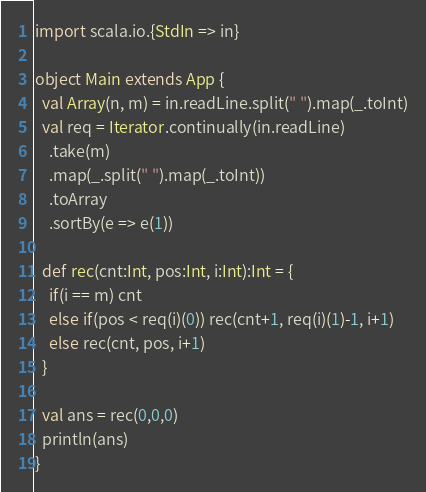Convert code to text. <code><loc_0><loc_0><loc_500><loc_500><_Scala_>import scala.io.{StdIn => in}

object Main extends App {
  val Array(n, m) = in.readLine.split(" ").map(_.toInt)
  val req = Iterator.continually(in.readLine)
    .take(m)
    .map(_.split(" ").map(_.toInt))
    .toArray
    .sortBy(e => e(1))

  def rec(cnt:Int, pos:Int, i:Int):Int = {
    if(i == m) cnt
    else if(pos < req(i)(0)) rec(cnt+1, req(i)(1)-1, i+1)
    else rec(cnt, pos, i+1)
  }

  val ans = rec(0,0,0)
  println(ans)
}</code> 